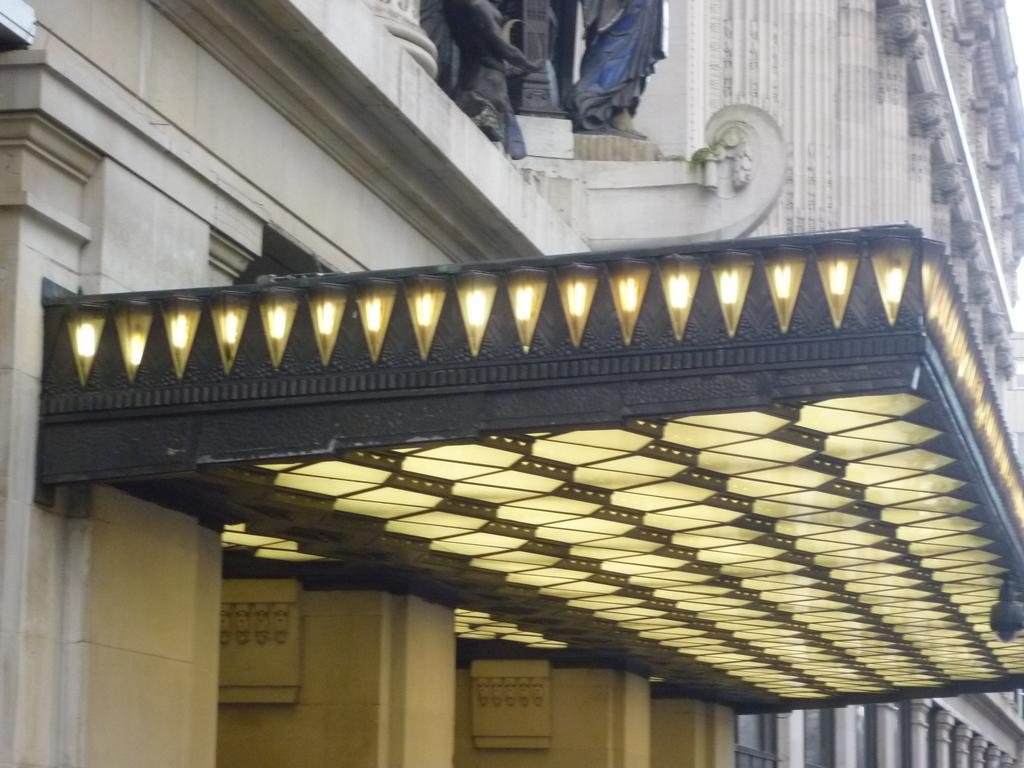What type of structure is present in the image? There is a building in the image. Can you describe the color of the building? The building is white in color. What other objects can be seen in the image besides the building? There are sculptures in the image. What is the color of the sculptures? The sculptures are black in color. What else is visible in the image? There are lights visible in the image. What type of cord is used to hang the prose in the image? There is no mention of a cord or prose in the image; it features a building, sculptures, and lights. 